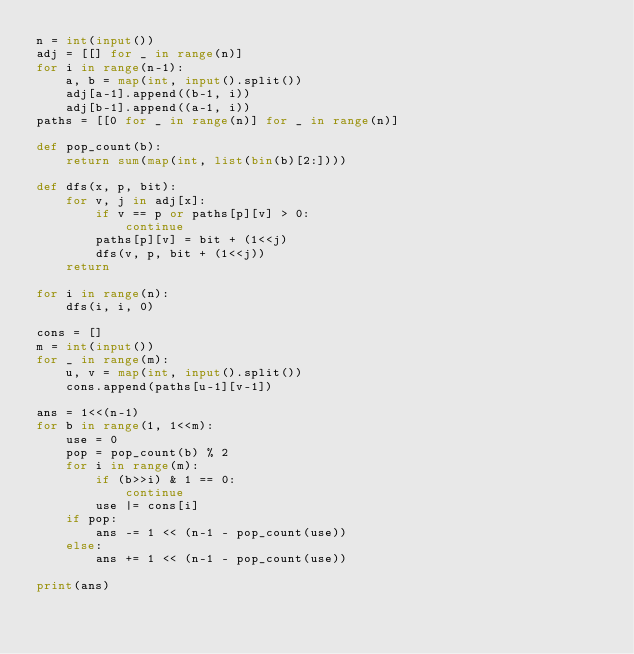Convert code to text. <code><loc_0><loc_0><loc_500><loc_500><_Python_>n = int(input())
adj = [[] for _ in range(n)]
for i in range(n-1):
	a, b = map(int, input().split())
	adj[a-1].append((b-1, i))
	adj[b-1].append((a-1, i))
paths = [[0 for _ in range(n)] for _ in range(n)]

def pop_count(b):
	return sum(map(int, list(bin(b)[2:])))

def dfs(x, p, bit):
	for v, j in adj[x]:
		if v == p or paths[p][v] > 0:
			continue
		paths[p][v] = bit + (1<<j)
		dfs(v, p, bit + (1<<j))
	return

for i in range(n):
	dfs(i, i, 0)

cons = []
m = int(input())
for _ in range(m):
	u, v = map(int, input().split())
	cons.append(paths[u-1][v-1])

ans = 1<<(n-1)
for b in range(1, 1<<m):
	use = 0
	pop = pop_count(b) % 2
	for i in range(m):
		if (b>>i) & 1 == 0:
			continue
		use |= cons[i]
	if pop:
		ans -= 1 << (n-1 - pop_count(use))
	else:
		ans += 1 << (n-1 - pop_count(use))

print(ans)</code> 